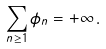Convert formula to latex. <formula><loc_0><loc_0><loc_500><loc_500>\sum _ { n \geq 1 } \phi _ { n } = + \infty \, .</formula> 